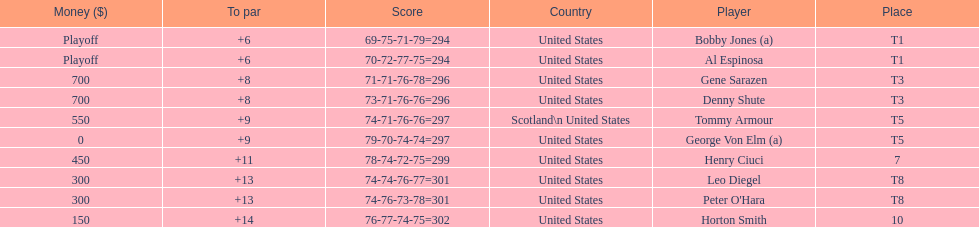Gene sarazen and denny shute are both from which country? United States. 